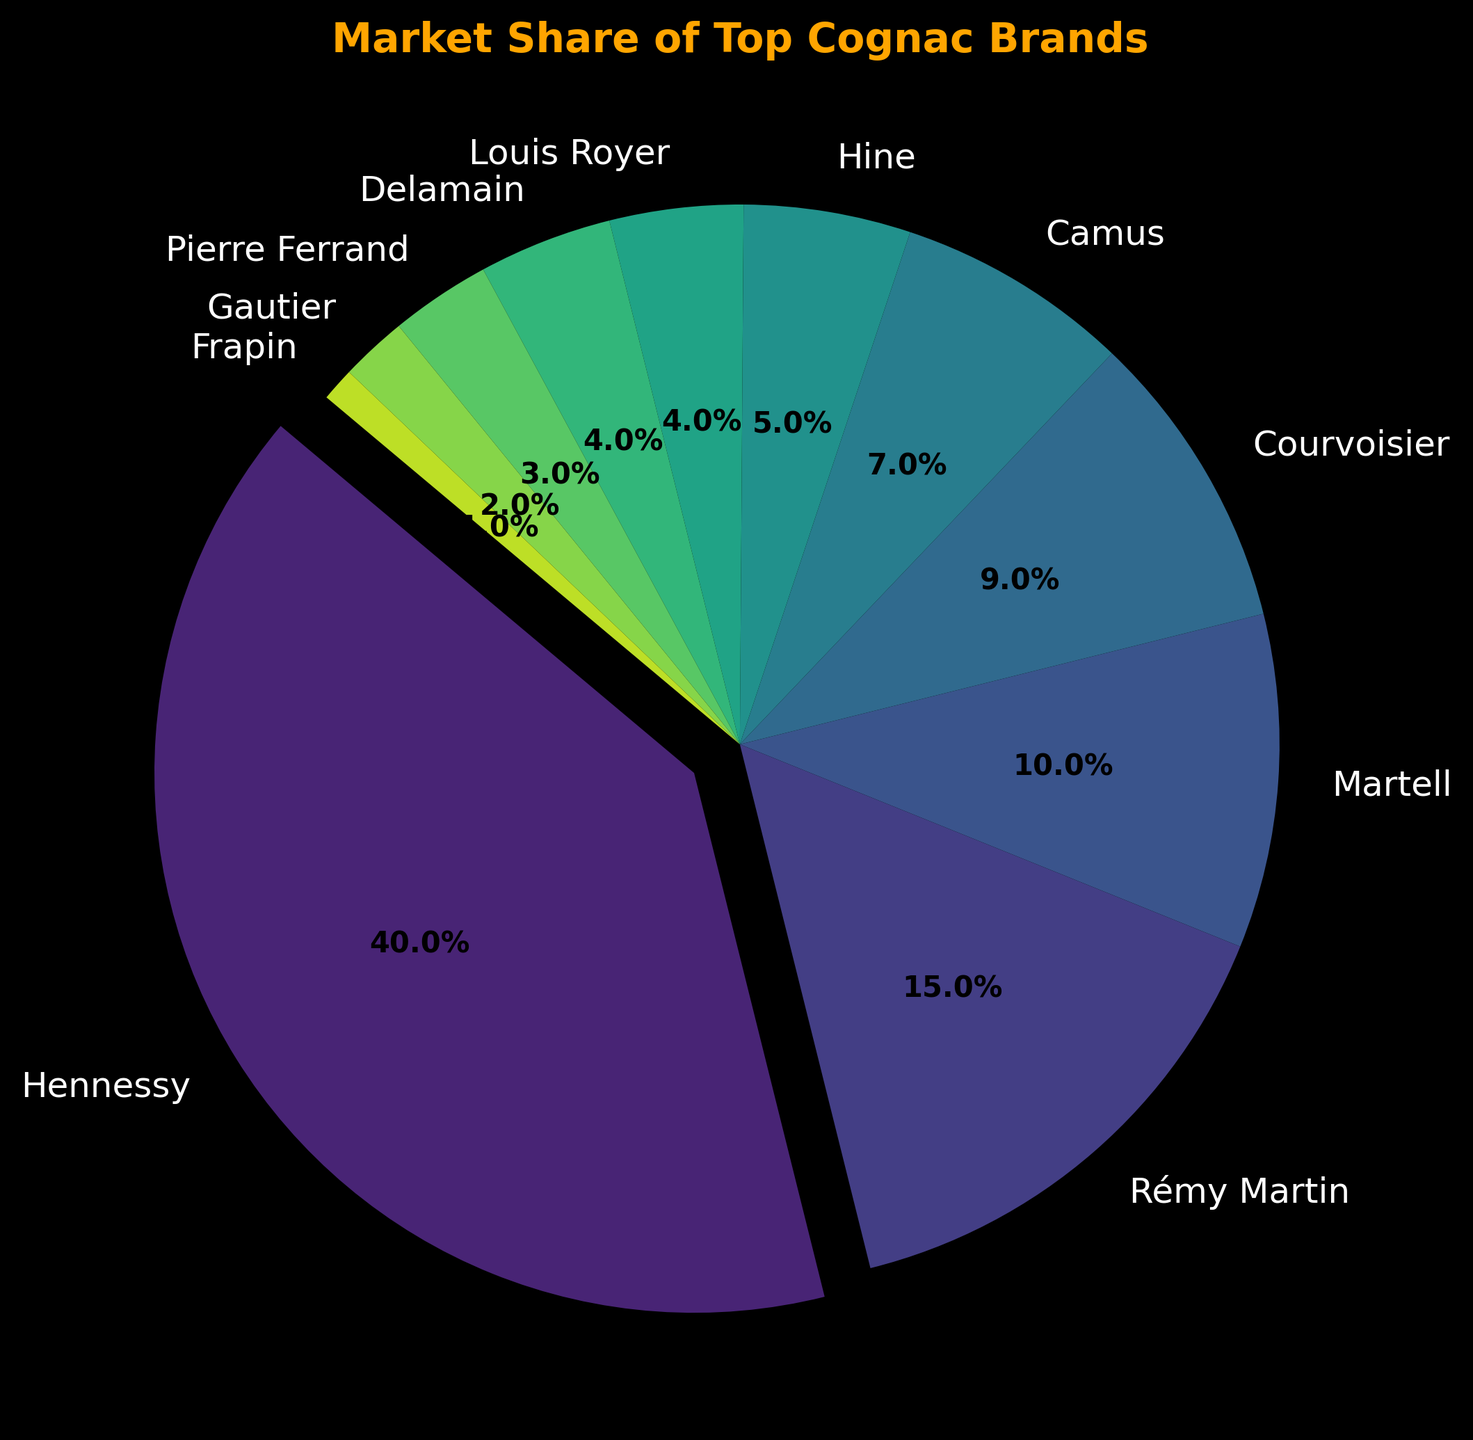What brand holds the largest market share? The brand with the largest portion of the pie chart is Hennessy. Its slice is also emphasized by being slightly separated from the rest.
Answer: Hennessy How much more market share does Hennessy have compared to Rémy Martin? Hennessy's market share is 40%, and Rémy Martin's is 15%. The difference is computed by subtracting 15 from 40.
Answer: 25% Which brands have an equal market share? The pie chart shows equal-sized slices for Louis Royer and Delamain, both indicating a market share of 4%.
Answer: Louis Royer and Delamain What proportion of the market do the four smallest brands together hold? The smallest brands are Pierre Ferrand, Gautier, and Frapin, with market shares of 3%, 2%, and 1% respectively. Adding these values together gives 3 + 2 + 1.
Answer: 6% Is the market share of Martell greater than Courvoisier and Camus combined? Martell has a market share of 10%, while Courvoisier and Camus combined hold 9% and 7%, totaling 16%.
Answer: No Which brand has a slightly larger market share than Camus but significantly smaller than Courvoisier? The chart reveals that Hine has a market share of 5%, which is slightly larger than Camus' 7% but does not compare to Courvoisier's 9%.
Answer: Hine How does the cumulative market share of Martell and Courvoisier compare to that of Hennessy? Martell's market share is 10%, and Courvoisier's is 9%. Their combined market share is 10 + 9, totaling 19%. Hennessy has a market share of 40%.
Answer: Less than Hennessy How much market share do the top three brands together hold? The top three brands are Hennessy (40%), Rémy Martin (15%), and Martell (10%). Their combined market share is 40 + 15 + 10.
Answer: 65% Between Camus and Hine, which brand has a smaller market share? The pie chart shows Camus at 7% and Hine at 5%.
Answer: Hine 